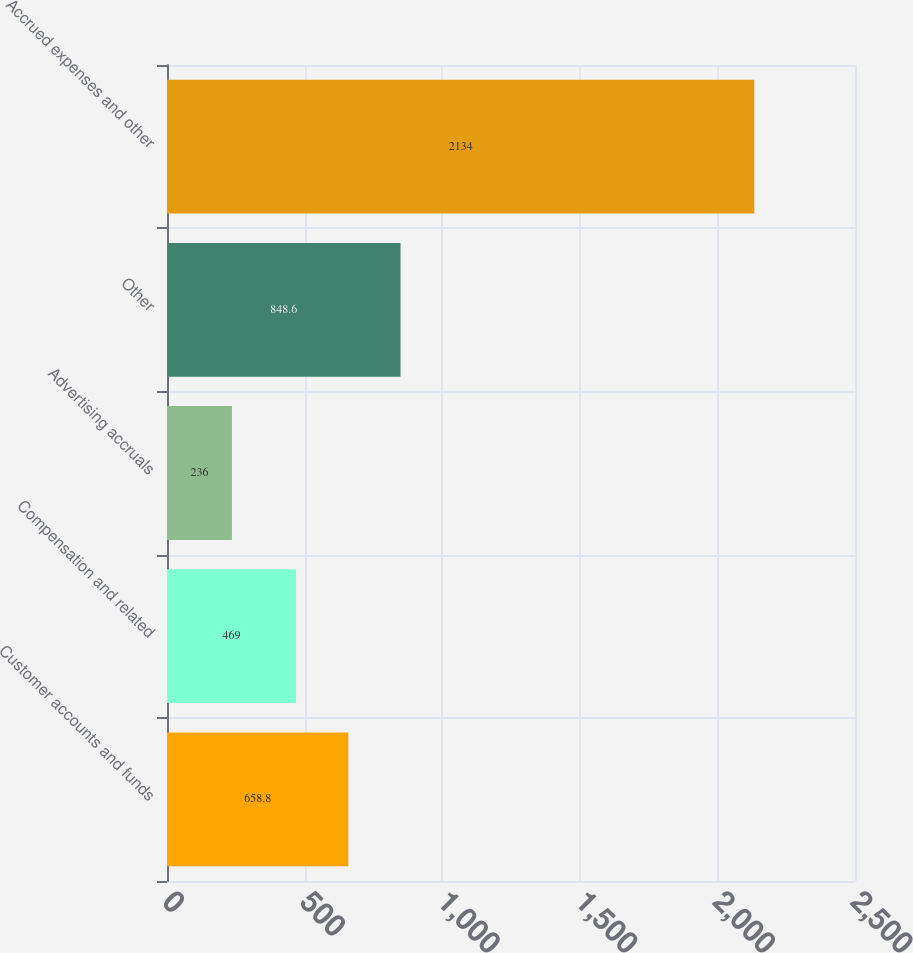Convert chart. <chart><loc_0><loc_0><loc_500><loc_500><bar_chart><fcel>Customer accounts and funds<fcel>Compensation and related<fcel>Advertising accruals<fcel>Other<fcel>Accrued expenses and other<nl><fcel>658.8<fcel>469<fcel>236<fcel>848.6<fcel>2134<nl></chart> 